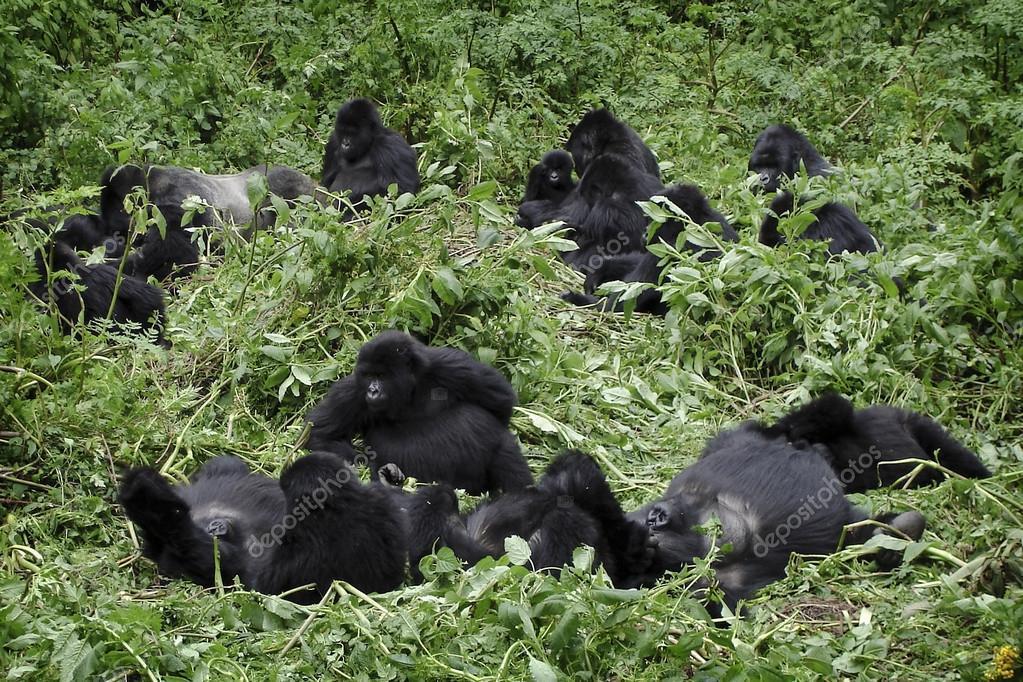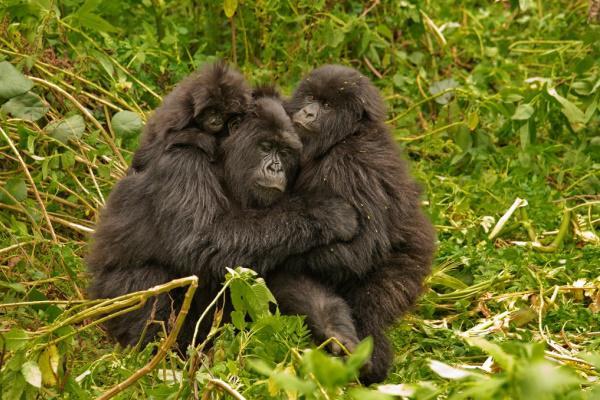The first image is the image on the left, the second image is the image on the right. For the images displayed, is the sentence "There are no more than two animals in a grassy area in the image on the right." factually correct? Answer yes or no. Yes. 